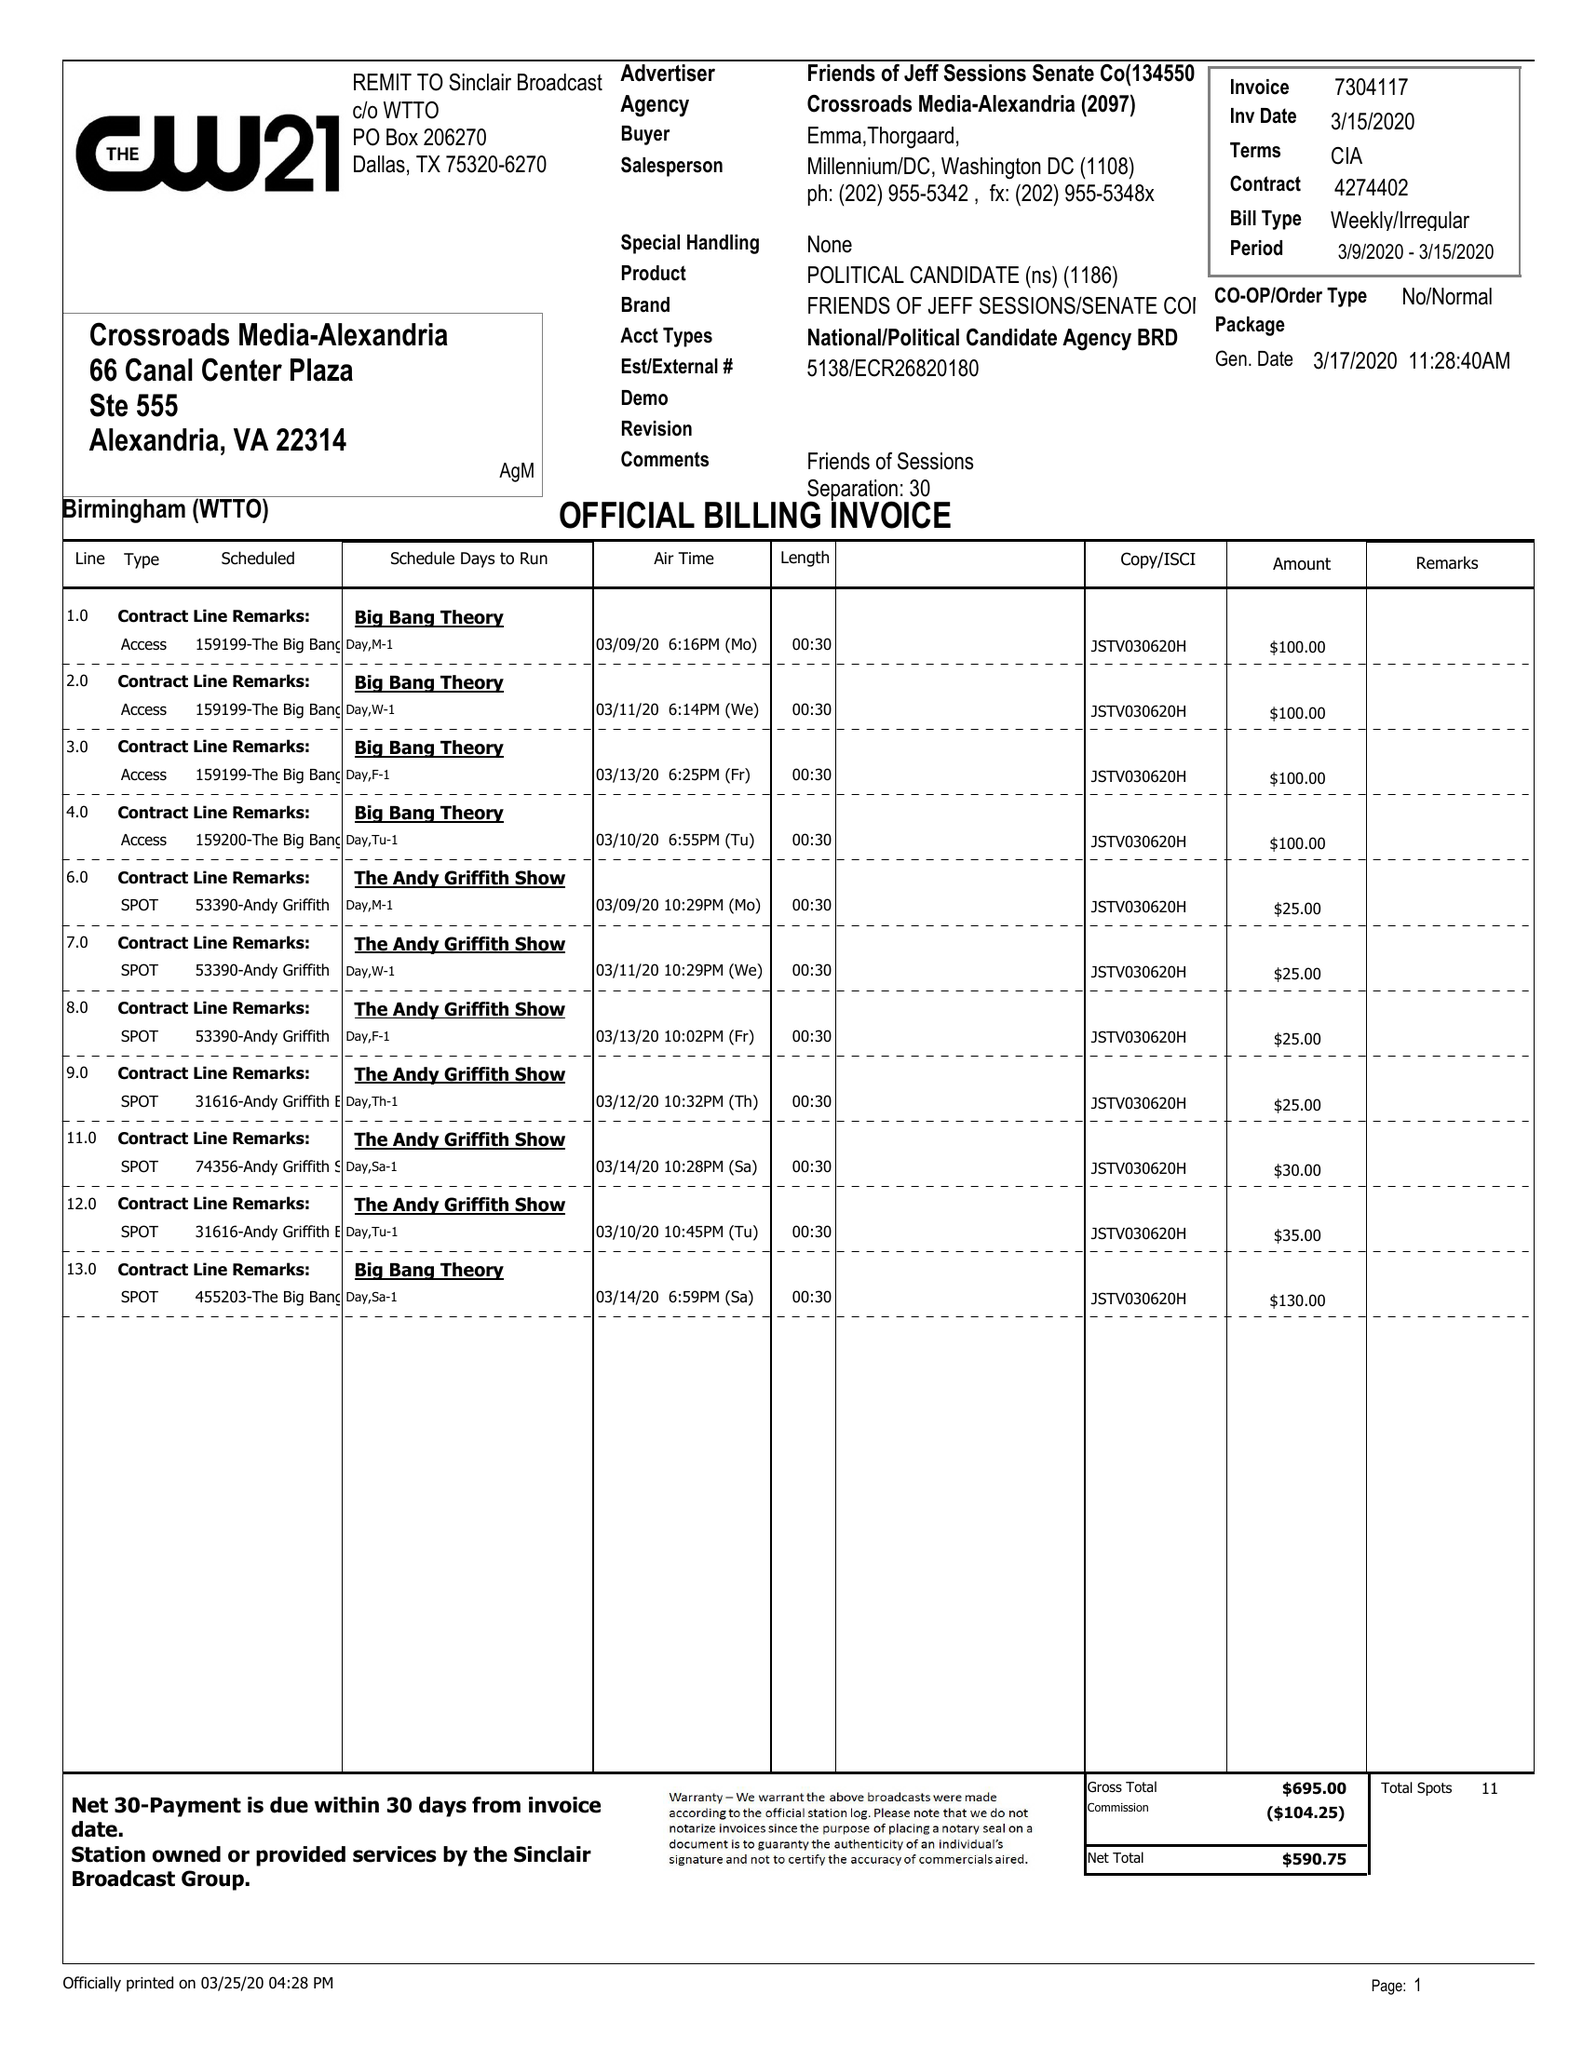What is the value for the contract_num?
Answer the question using a single word or phrase. 4274402 